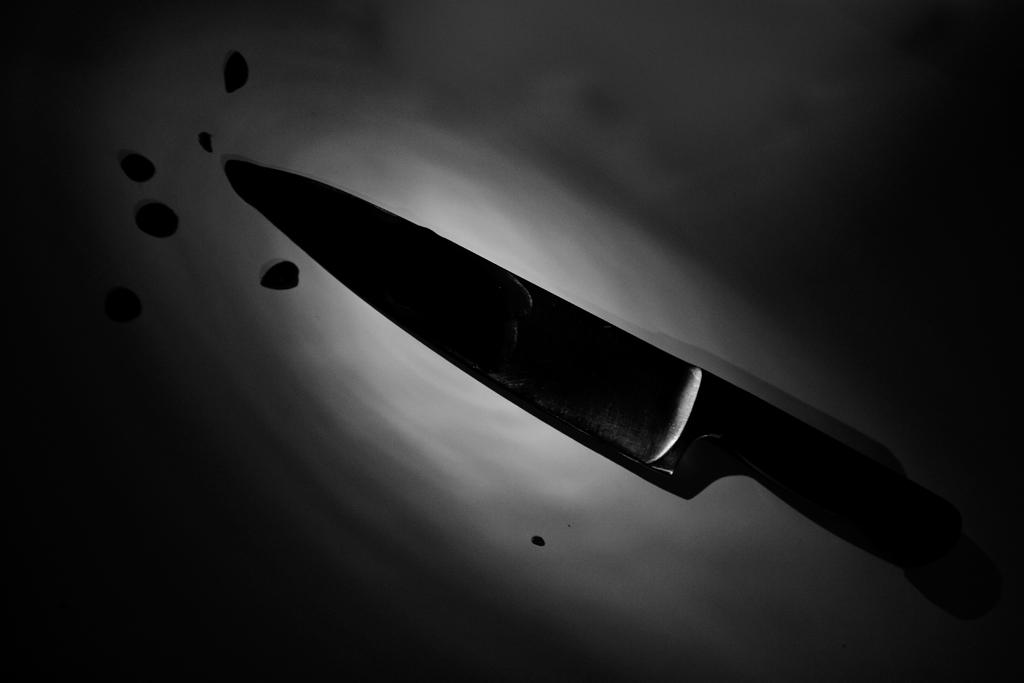What object can be seen in the image? There is a knife in the image. Where is the knife located? The knife is on some surface. What type of music can be heard coming from the knife in the image? There is no music associated with the knife in the image. 